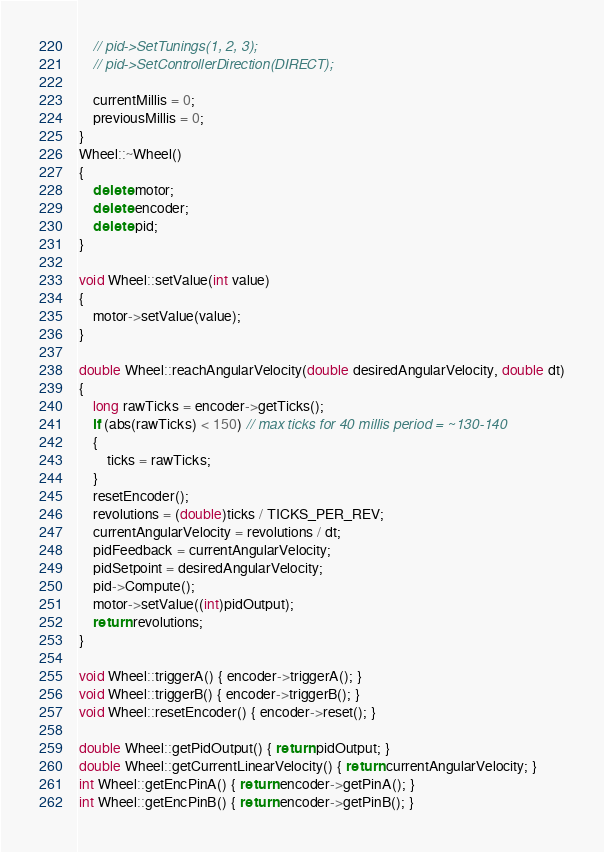Convert code to text. <code><loc_0><loc_0><loc_500><loc_500><_C++_>    // pid->SetTunings(1, 2, 3);
    // pid->SetControllerDirection(DIRECT);

    currentMillis = 0;
    previousMillis = 0;
}
Wheel::~Wheel()
{
    delete motor;
    delete encoder;
    delete pid;
}

void Wheel::setValue(int value)
{
    motor->setValue(value);
}

double Wheel::reachAngularVelocity(double desiredAngularVelocity, double dt)
{
    long rawTicks = encoder->getTicks();
    if (abs(rawTicks) < 150) // max ticks for 40 millis period = ~130-140
    {
        ticks = rawTicks;
    }
    resetEncoder();
    revolutions = (double)ticks / TICKS_PER_REV;
    currentAngularVelocity = revolutions / dt;
    pidFeedback = currentAngularVelocity;
    pidSetpoint = desiredAngularVelocity;
    pid->Compute();
    motor->setValue((int)pidOutput);
    return revolutions;
}

void Wheel::triggerA() { encoder->triggerA(); }
void Wheel::triggerB() { encoder->triggerB(); }
void Wheel::resetEncoder() { encoder->reset(); }

double Wheel::getPidOutput() { return pidOutput; }
double Wheel::getCurrentLinearVelocity() { return currentAngularVelocity; }
int Wheel::getEncPinA() { return encoder->getPinA(); }
int Wheel::getEncPinB() { return encoder->getPinB(); }</code> 